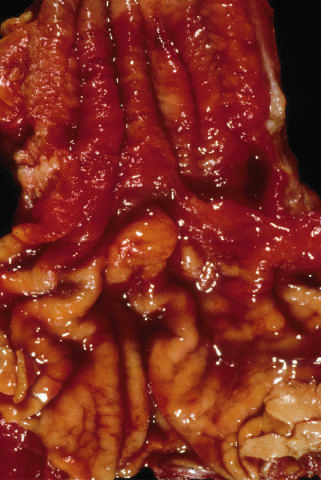do only a few areas of pale squamous mucosa remain within the predominantly metaplastic, reddish mucosa of the distal esophagus?
Answer the question using a single word or phrase. Yes 